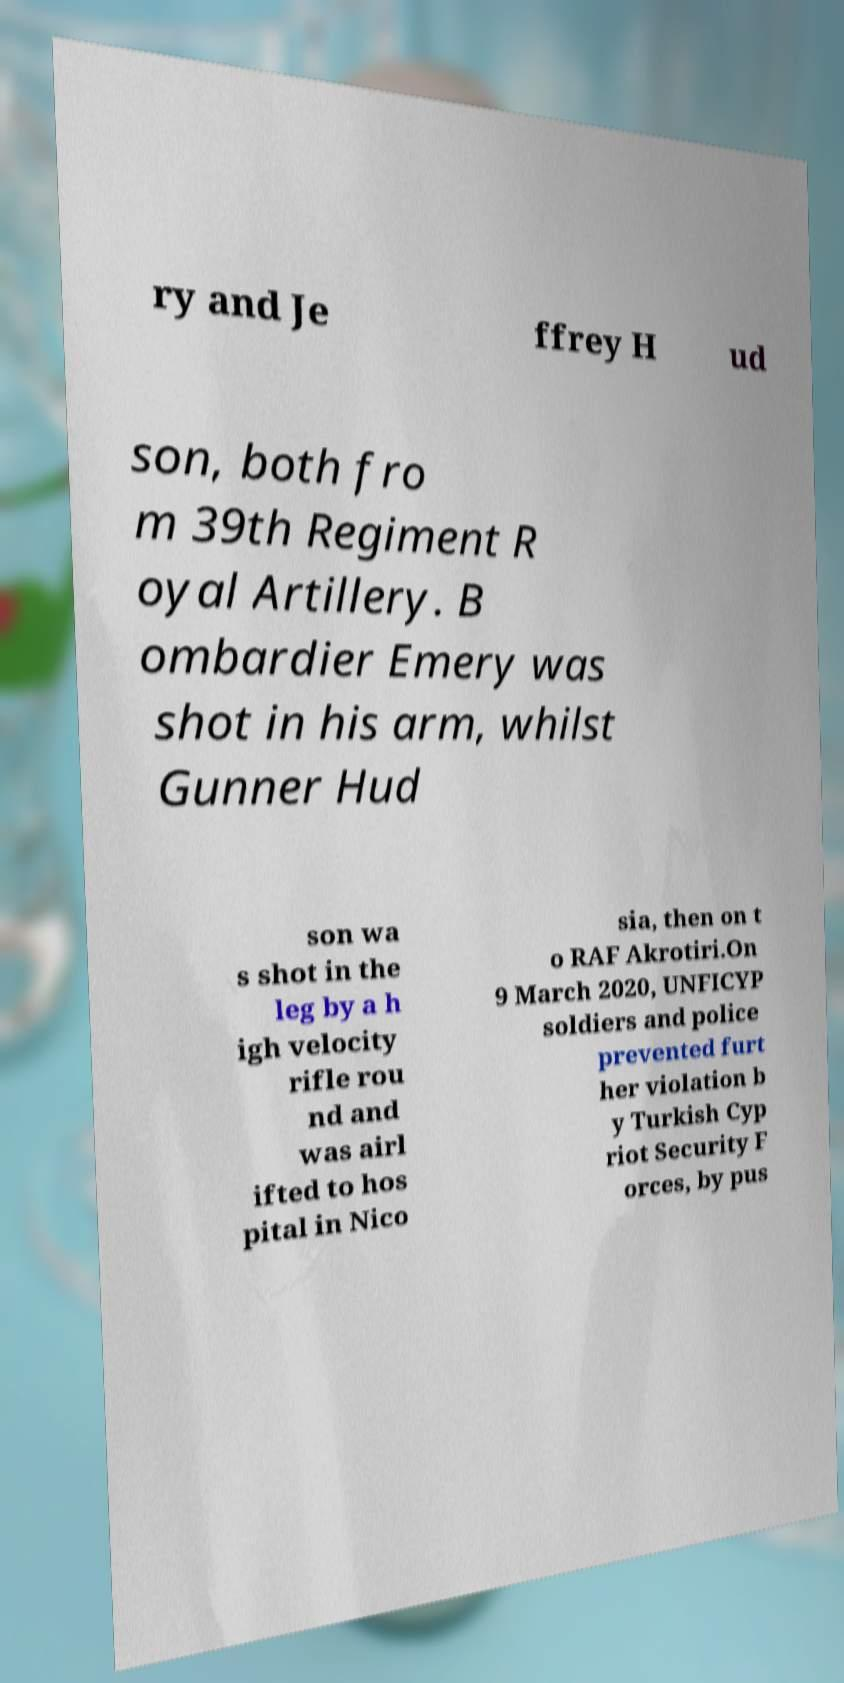There's text embedded in this image that I need extracted. Can you transcribe it verbatim? ry and Je ffrey H ud son, both fro m 39th Regiment R oyal Artillery. B ombardier Emery was shot in his arm, whilst Gunner Hud son wa s shot in the leg by a h igh velocity rifle rou nd and was airl ifted to hos pital in Nico sia, then on t o RAF Akrotiri.On 9 March 2020, UNFICYP soldiers and police prevented furt her violation b y Turkish Cyp riot Security F orces, by pus 